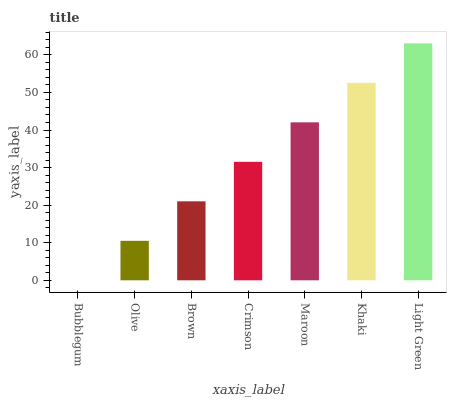Is Olive the minimum?
Answer yes or no. No. Is Olive the maximum?
Answer yes or no. No. Is Olive greater than Bubblegum?
Answer yes or no. Yes. Is Bubblegum less than Olive?
Answer yes or no. Yes. Is Bubblegum greater than Olive?
Answer yes or no. No. Is Olive less than Bubblegum?
Answer yes or no. No. Is Crimson the high median?
Answer yes or no. Yes. Is Crimson the low median?
Answer yes or no. Yes. Is Khaki the high median?
Answer yes or no. No. Is Maroon the low median?
Answer yes or no. No. 